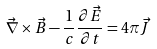<formula> <loc_0><loc_0><loc_500><loc_500>\vec { \nabla } \times \vec { B } - \frac { 1 } { c } \frac { \partial \vec { E } } { \partial t } = 4 \pi \vec { J }</formula> 